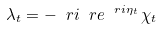<formula> <loc_0><loc_0><loc_500><loc_500>\lambda _ { t } = - \ r i \ r e ^ { \ r i \eta _ { t } } \, \chi _ { t }</formula> 